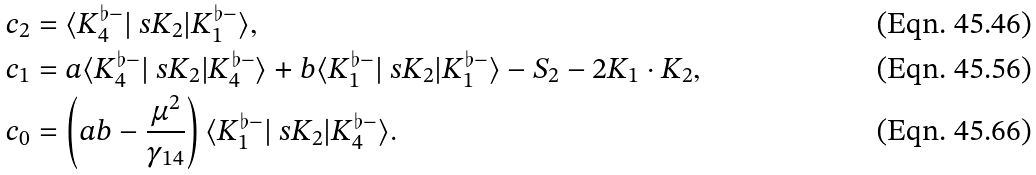<formula> <loc_0><loc_0><loc_500><loc_500>c _ { 2 } & = \langle K _ { 4 } ^ { \flat - } | \ s { K } _ { 2 } | K _ { 1 } ^ { \flat - } \rangle , \\ c _ { 1 } & = a \langle K _ { 4 } ^ { \flat - } | \ s { K } _ { 2 } | K _ { 4 } ^ { \flat - } \rangle + b \langle K _ { 1 } ^ { \flat - } | \ s { K } _ { 2 } | K _ { 1 } ^ { \flat - } \rangle - S _ { 2 } - 2 K _ { 1 } \cdot K _ { 2 } , \\ c _ { 0 } & = \left ( a b - \frac { \mu ^ { 2 } } { \gamma _ { 1 4 } } \right ) \langle K _ { 1 } ^ { \flat - } | \ s { K } _ { 2 } | K _ { 4 } ^ { \flat - } \rangle .</formula> 